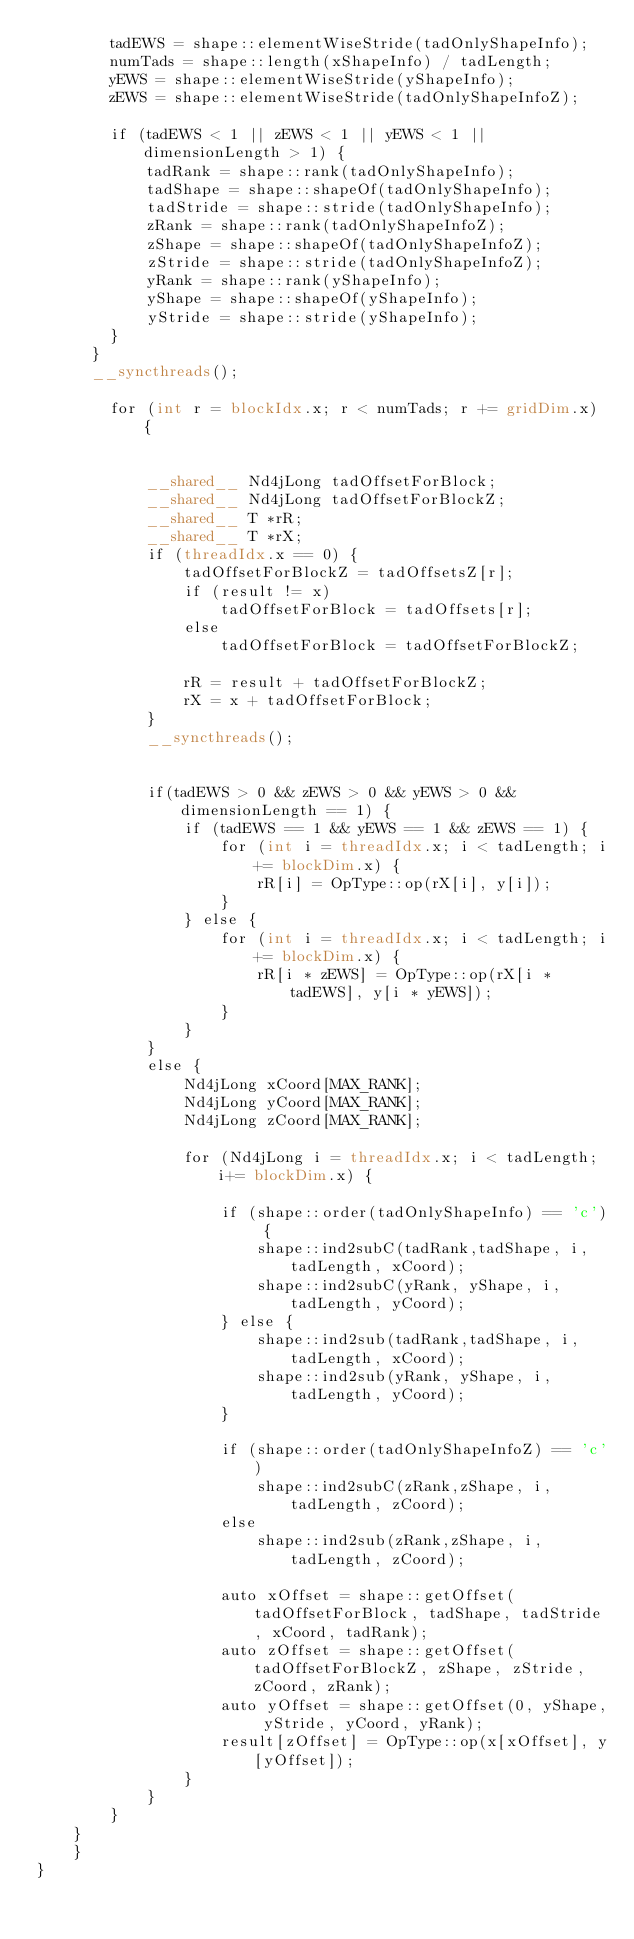Convert code to text. <code><loc_0><loc_0><loc_500><loc_500><_Cuda_>        tadEWS = shape::elementWiseStride(tadOnlyShapeInfo);
        numTads = shape::length(xShapeInfo) / tadLength;
        yEWS = shape::elementWiseStride(yShapeInfo);
      	zEWS = shape::elementWiseStride(tadOnlyShapeInfoZ);

        if (tadEWS < 1 || zEWS < 1 || yEWS < 1 || dimensionLength > 1) {
            tadRank = shape::rank(tadOnlyShapeInfo);
            tadShape = shape::shapeOf(tadOnlyShapeInfo);
      	    tadStride = shape::stride(tadOnlyShapeInfo);
      	    zRank = shape::rank(tadOnlyShapeInfoZ);
      	    zShape = shape::shapeOf(tadOnlyShapeInfoZ);
      	    zStride = shape::stride(tadOnlyShapeInfoZ);
      	    yRank = shape::rank(yShapeInfo);
      	    yShape = shape::shapeOf(yShapeInfo);
      	    yStride = shape::stride(yShapeInfo);
        }
      }
      __syncthreads();

		for (int r = blockIdx.x; r < numTads; r += gridDim.x) {


            __shared__ Nd4jLong tadOffsetForBlock;
            __shared__ Nd4jLong tadOffsetForBlockZ;
            __shared__ T *rR;
            __shared__ T *rX;
            if (threadIdx.x == 0) {
                tadOffsetForBlockZ = tadOffsetsZ[r];
                if (result != x)
                    tadOffsetForBlock = tadOffsets[r];
                else
                    tadOffsetForBlock = tadOffsetForBlockZ;

                rR = result + tadOffsetForBlockZ;
                rX = x + tadOffsetForBlock;
            }
            __syncthreads();


            if(tadEWS > 0 && zEWS > 0 && yEWS > 0 && dimensionLength == 1) {
            	if (tadEWS == 1 && yEWS == 1 && zEWS == 1) {
                	for (int i = threadIdx.x; i < tadLength; i+= blockDim.x) {
                    	rR[i] = OpType::op(rX[i], y[i]);
                	}
                } else {
					for (int i = threadIdx.x; i < tadLength; i+= blockDim.x) {
                    	rR[i * zEWS] = OpType::op(rX[i * tadEWS], y[i * yEWS]);
                	}
                }
            }
            else {
                Nd4jLong xCoord[MAX_RANK];
                Nd4jLong yCoord[MAX_RANK];
                Nd4jLong zCoord[MAX_RANK];

                for (Nd4jLong i = threadIdx.x; i < tadLength; i+= blockDim.x) {

                    if (shape::order(tadOnlyShapeInfo) == 'c') {
                        shape::ind2subC(tadRank,tadShape, i, tadLength, xCoord);
                        shape::ind2subC(yRank, yShape, i, tadLength, yCoord);
                    } else {
                        shape::ind2sub(tadRank,tadShape, i, tadLength, xCoord);
                        shape::ind2sub(yRank, yShape, i, tadLength, yCoord);
                    }

                    if (shape::order(tadOnlyShapeInfoZ) == 'c')
                        shape::ind2subC(zRank,zShape, i, tadLength, zCoord);
                    else
                        shape::ind2sub(zRank,zShape, i, tadLength, zCoord);

                    auto xOffset = shape::getOffset(tadOffsetForBlock, tadShape, tadStride, xCoord, tadRank);
                    auto zOffset = shape::getOffset(tadOffsetForBlockZ, zShape, zStride, zCoord, zRank);
                    auto yOffset = shape::getOffset(0, yShape, yStride, yCoord, yRank);
                    result[zOffset] = OpType::op(x[xOffset], y[yOffset]);
                }
            }
		}
	}
    }
}</code> 